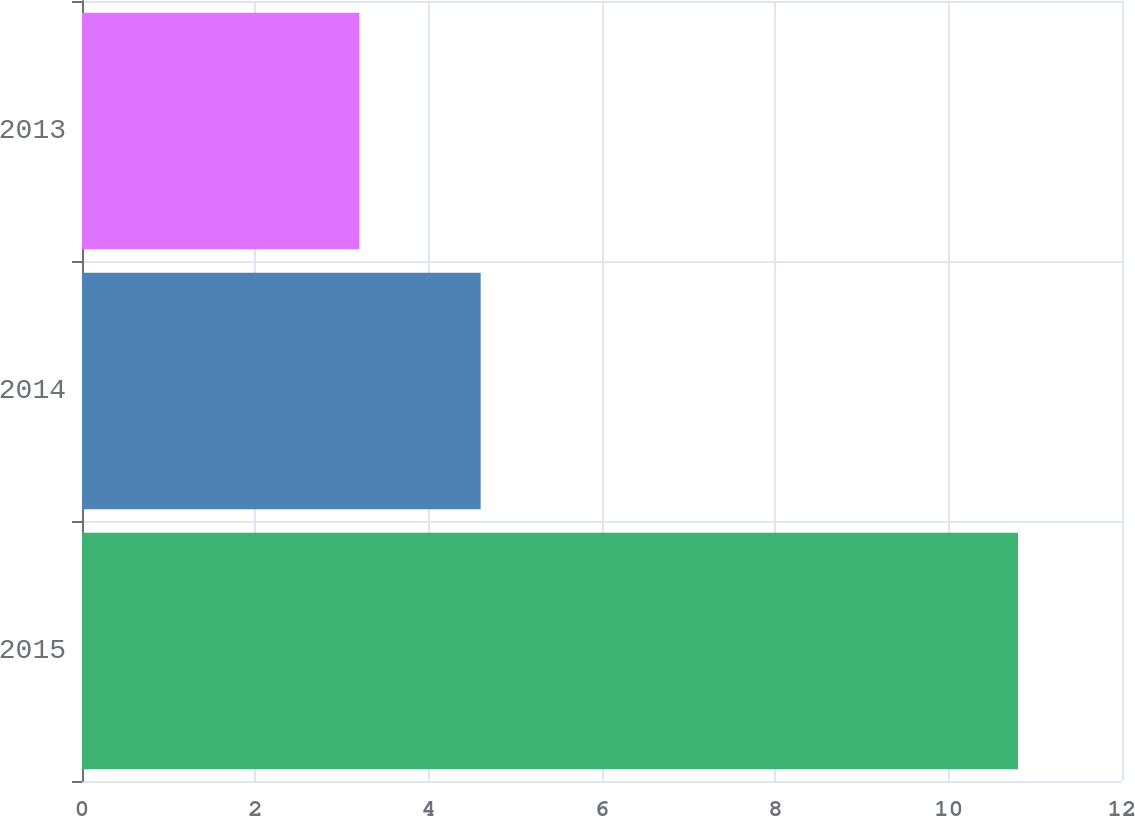<chart> <loc_0><loc_0><loc_500><loc_500><bar_chart><fcel>2015<fcel>2014<fcel>2013<nl><fcel>10.8<fcel>4.6<fcel>3.2<nl></chart> 